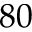Convert formula to latex. <formula><loc_0><loc_0><loc_500><loc_500>8 0</formula> 